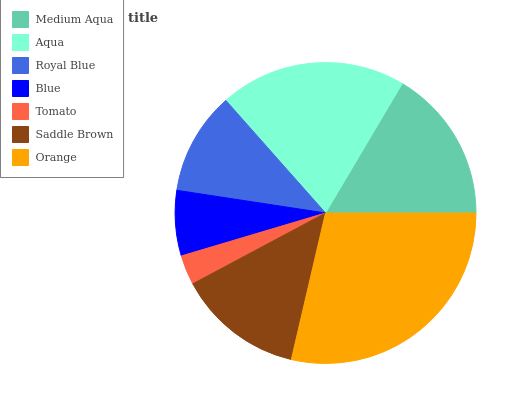Is Tomato the minimum?
Answer yes or no. Yes. Is Orange the maximum?
Answer yes or no. Yes. Is Aqua the minimum?
Answer yes or no. No. Is Aqua the maximum?
Answer yes or no. No. Is Aqua greater than Medium Aqua?
Answer yes or no. Yes. Is Medium Aqua less than Aqua?
Answer yes or no. Yes. Is Medium Aqua greater than Aqua?
Answer yes or no. No. Is Aqua less than Medium Aqua?
Answer yes or no. No. Is Saddle Brown the high median?
Answer yes or no. Yes. Is Saddle Brown the low median?
Answer yes or no. Yes. Is Orange the high median?
Answer yes or no. No. Is Medium Aqua the low median?
Answer yes or no. No. 